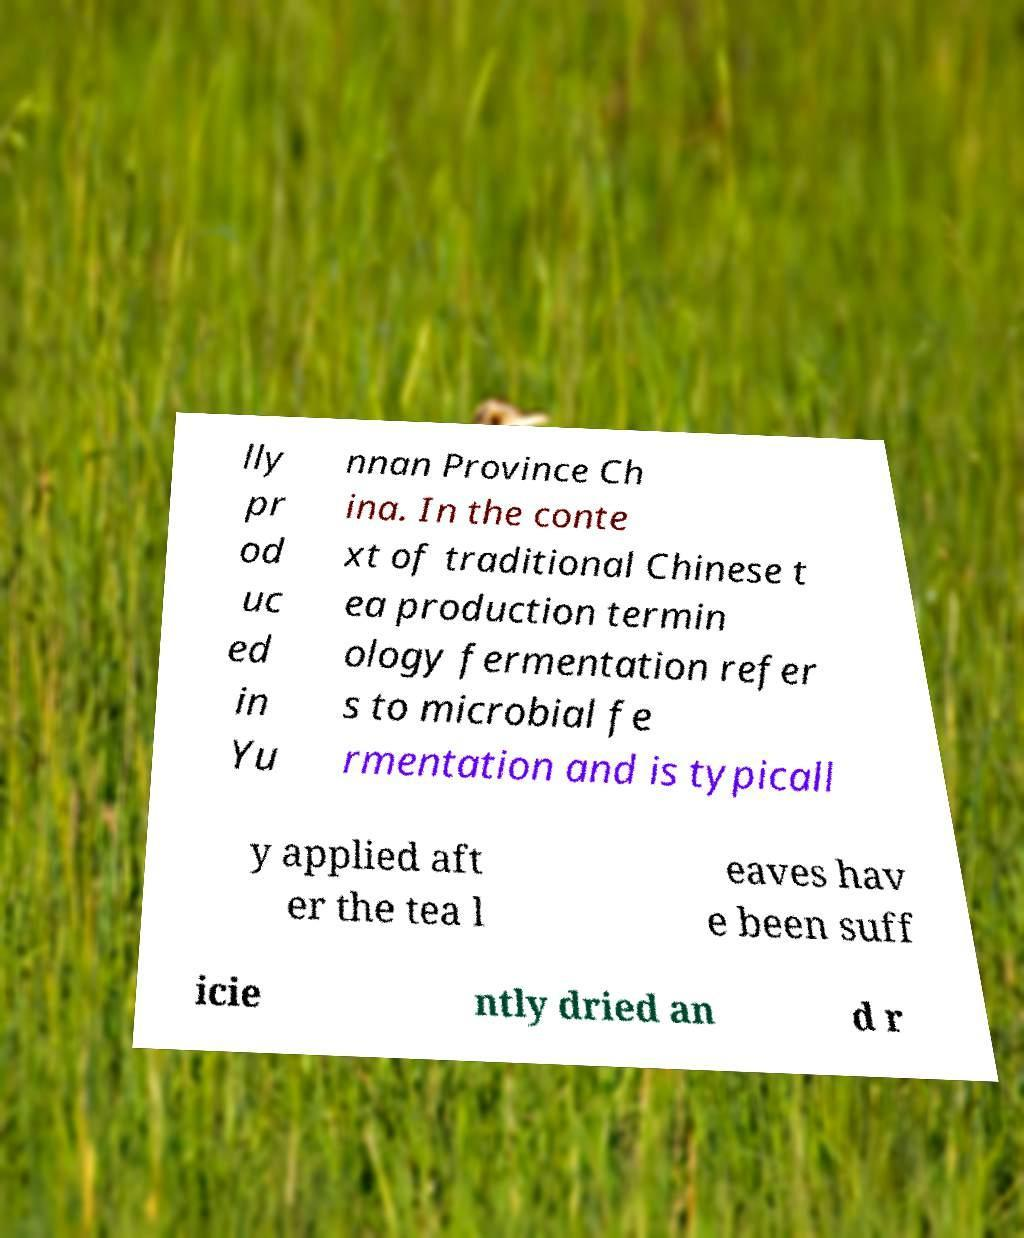There's text embedded in this image that I need extracted. Can you transcribe it verbatim? lly pr od uc ed in Yu nnan Province Ch ina. In the conte xt of traditional Chinese t ea production termin ology fermentation refer s to microbial fe rmentation and is typicall y applied aft er the tea l eaves hav e been suff icie ntly dried an d r 